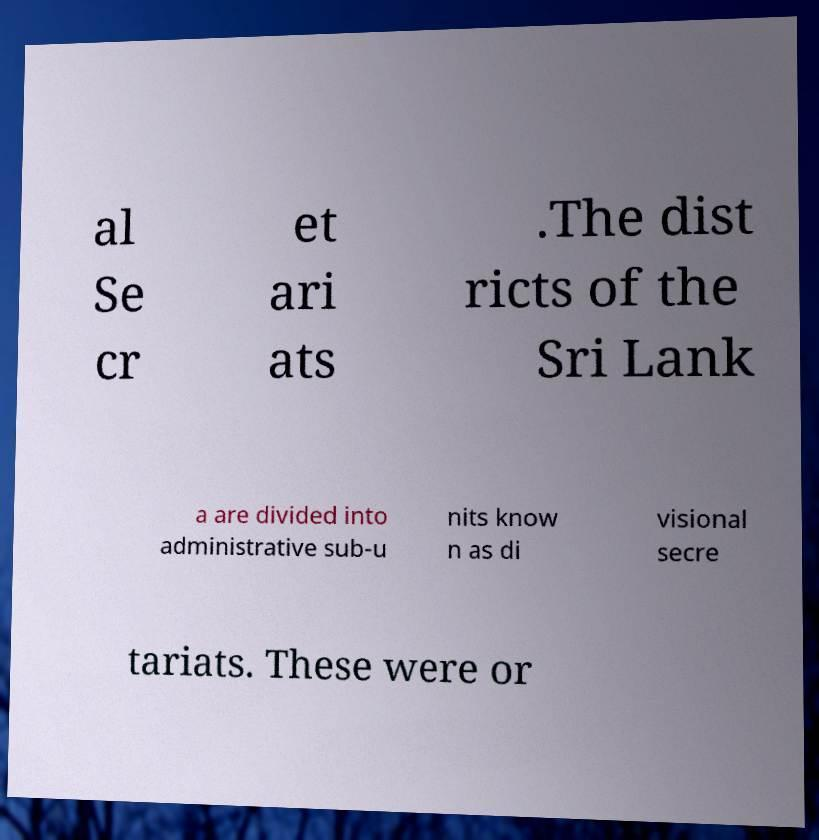There's text embedded in this image that I need extracted. Can you transcribe it verbatim? al Se cr et ari ats .The dist ricts of the Sri Lank a are divided into administrative sub-u nits know n as di visional secre tariats. These were or 